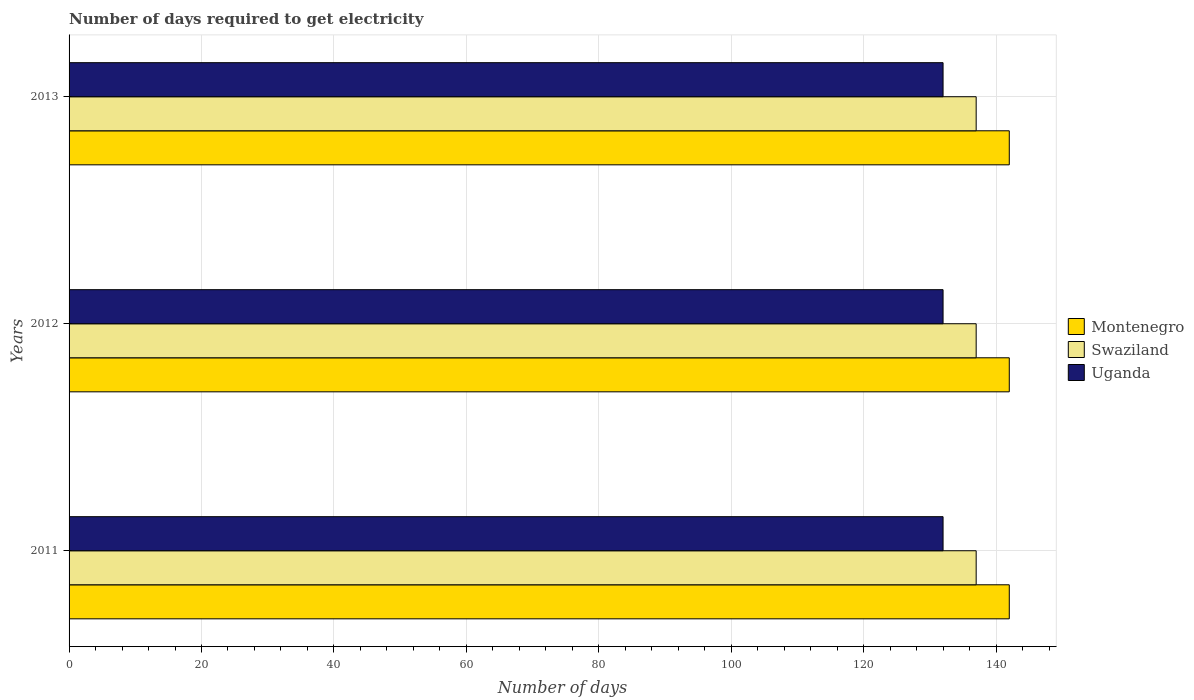How many different coloured bars are there?
Provide a succinct answer. 3. How many groups of bars are there?
Your answer should be compact. 3. What is the label of the 1st group of bars from the top?
Keep it short and to the point. 2013. In how many cases, is the number of bars for a given year not equal to the number of legend labels?
Ensure brevity in your answer.  0. What is the number of days required to get electricity in in Uganda in 2012?
Provide a short and direct response. 132. Across all years, what is the maximum number of days required to get electricity in in Montenegro?
Keep it short and to the point. 142. Across all years, what is the minimum number of days required to get electricity in in Montenegro?
Ensure brevity in your answer.  142. What is the total number of days required to get electricity in in Swaziland in the graph?
Your answer should be compact. 411. What is the difference between the number of days required to get electricity in in Uganda in 2013 and the number of days required to get electricity in in Montenegro in 2012?
Your answer should be compact. -10. What is the average number of days required to get electricity in in Swaziland per year?
Offer a terse response. 137. In the year 2013, what is the difference between the number of days required to get electricity in in Uganda and number of days required to get electricity in in Swaziland?
Offer a terse response. -5. What is the ratio of the number of days required to get electricity in in Swaziland in 2011 to that in 2013?
Your answer should be compact. 1. Is the number of days required to get electricity in in Swaziland in 2012 less than that in 2013?
Provide a succinct answer. No. Is the difference between the number of days required to get electricity in in Uganda in 2012 and 2013 greater than the difference between the number of days required to get electricity in in Swaziland in 2012 and 2013?
Keep it short and to the point. No. What is the difference between the highest and the second highest number of days required to get electricity in in Uganda?
Ensure brevity in your answer.  0. What is the difference between the highest and the lowest number of days required to get electricity in in Montenegro?
Your response must be concise. 0. In how many years, is the number of days required to get electricity in in Swaziland greater than the average number of days required to get electricity in in Swaziland taken over all years?
Provide a succinct answer. 0. Is the sum of the number of days required to get electricity in in Montenegro in 2011 and 2013 greater than the maximum number of days required to get electricity in in Swaziland across all years?
Make the answer very short. Yes. What does the 1st bar from the top in 2011 represents?
Ensure brevity in your answer.  Uganda. What does the 1st bar from the bottom in 2012 represents?
Offer a very short reply. Montenegro. Is it the case that in every year, the sum of the number of days required to get electricity in in Montenegro and number of days required to get electricity in in Uganda is greater than the number of days required to get electricity in in Swaziland?
Make the answer very short. Yes. How many bars are there?
Your answer should be compact. 9. Are all the bars in the graph horizontal?
Offer a terse response. Yes. How many years are there in the graph?
Ensure brevity in your answer.  3. Are the values on the major ticks of X-axis written in scientific E-notation?
Offer a very short reply. No. Does the graph contain grids?
Ensure brevity in your answer.  Yes. What is the title of the graph?
Keep it short and to the point. Number of days required to get electricity. What is the label or title of the X-axis?
Ensure brevity in your answer.  Number of days. What is the Number of days in Montenegro in 2011?
Offer a terse response. 142. What is the Number of days in Swaziland in 2011?
Provide a short and direct response. 137. What is the Number of days in Uganda in 2011?
Ensure brevity in your answer.  132. What is the Number of days in Montenegro in 2012?
Ensure brevity in your answer.  142. What is the Number of days of Swaziland in 2012?
Ensure brevity in your answer.  137. What is the Number of days in Uganda in 2012?
Ensure brevity in your answer.  132. What is the Number of days of Montenegro in 2013?
Give a very brief answer. 142. What is the Number of days in Swaziland in 2013?
Your response must be concise. 137. What is the Number of days in Uganda in 2013?
Make the answer very short. 132. Across all years, what is the maximum Number of days in Montenegro?
Provide a succinct answer. 142. Across all years, what is the maximum Number of days of Swaziland?
Your answer should be compact. 137. Across all years, what is the maximum Number of days of Uganda?
Ensure brevity in your answer.  132. Across all years, what is the minimum Number of days of Montenegro?
Offer a terse response. 142. Across all years, what is the minimum Number of days of Swaziland?
Offer a terse response. 137. Across all years, what is the minimum Number of days in Uganda?
Your answer should be very brief. 132. What is the total Number of days of Montenegro in the graph?
Keep it short and to the point. 426. What is the total Number of days in Swaziland in the graph?
Keep it short and to the point. 411. What is the total Number of days of Uganda in the graph?
Your answer should be compact. 396. What is the difference between the Number of days of Swaziland in 2011 and that in 2012?
Make the answer very short. 0. What is the difference between the Number of days in Uganda in 2011 and that in 2012?
Offer a very short reply. 0. What is the difference between the Number of days of Swaziland in 2011 and that in 2013?
Your response must be concise. 0. What is the difference between the Number of days of Swaziland in 2012 and that in 2013?
Keep it short and to the point. 0. What is the difference between the Number of days in Uganda in 2012 and that in 2013?
Offer a terse response. 0. What is the difference between the Number of days in Montenegro in 2011 and the Number of days in Swaziland in 2012?
Keep it short and to the point. 5. What is the difference between the Number of days in Swaziland in 2011 and the Number of days in Uganda in 2012?
Provide a succinct answer. 5. What is the difference between the Number of days in Swaziland in 2011 and the Number of days in Uganda in 2013?
Offer a terse response. 5. What is the difference between the Number of days of Swaziland in 2012 and the Number of days of Uganda in 2013?
Your answer should be very brief. 5. What is the average Number of days of Montenegro per year?
Your answer should be compact. 142. What is the average Number of days in Swaziland per year?
Make the answer very short. 137. What is the average Number of days of Uganda per year?
Your response must be concise. 132. In the year 2011, what is the difference between the Number of days of Montenegro and Number of days of Uganda?
Make the answer very short. 10. In the year 2011, what is the difference between the Number of days in Swaziland and Number of days in Uganda?
Give a very brief answer. 5. In the year 2012, what is the difference between the Number of days of Montenegro and Number of days of Swaziland?
Provide a short and direct response. 5. In the year 2012, what is the difference between the Number of days in Swaziland and Number of days in Uganda?
Your answer should be very brief. 5. In the year 2013, what is the difference between the Number of days in Swaziland and Number of days in Uganda?
Provide a short and direct response. 5. What is the ratio of the Number of days in Uganda in 2011 to that in 2012?
Make the answer very short. 1. What is the ratio of the Number of days of Uganda in 2011 to that in 2013?
Offer a very short reply. 1. What is the ratio of the Number of days in Montenegro in 2012 to that in 2013?
Give a very brief answer. 1. What is the ratio of the Number of days in Swaziland in 2012 to that in 2013?
Make the answer very short. 1. What is the ratio of the Number of days of Uganda in 2012 to that in 2013?
Keep it short and to the point. 1. What is the difference between the highest and the second highest Number of days in Montenegro?
Provide a succinct answer. 0. What is the difference between the highest and the second highest Number of days of Swaziland?
Your answer should be compact. 0. What is the difference between the highest and the second highest Number of days of Uganda?
Provide a succinct answer. 0. What is the difference between the highest and the lowest Number of days in Swaziland?
Ensure brevity in your answer.  0. 